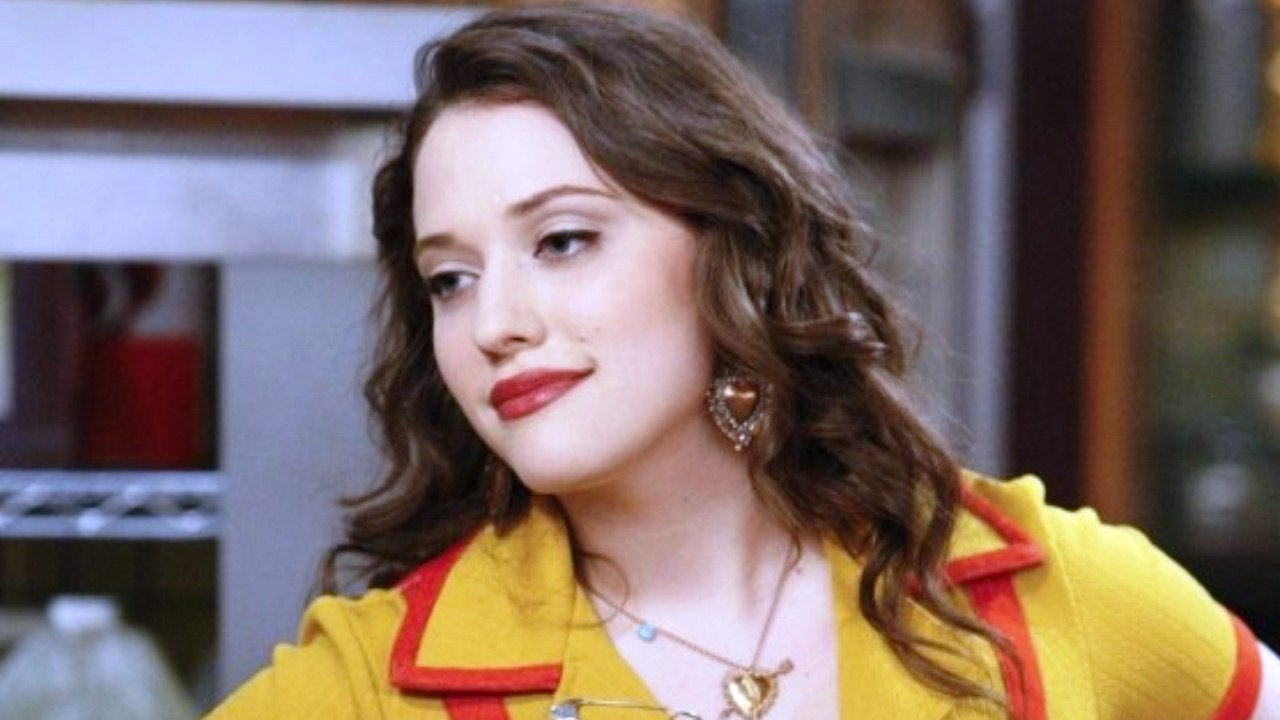Can you describe the main features of this image for me? The image features a young woman poised with a thoughtful expression. She's styled in a striking yellow cardigan with a bold red collar that adds a pop of contrast. Her accessories, a gold locket necklace and ornate brown earrings, pair elegantly with her attire, complementing her softly curled brown hair. Her makeup, highlighted by red lipstick, enhances her thoughtful expression, suggesting she might be in a moment of introspection or casual conversation. This ensemble portrays a vivid and stylish character, potentially from a modern, upbeat television show. 